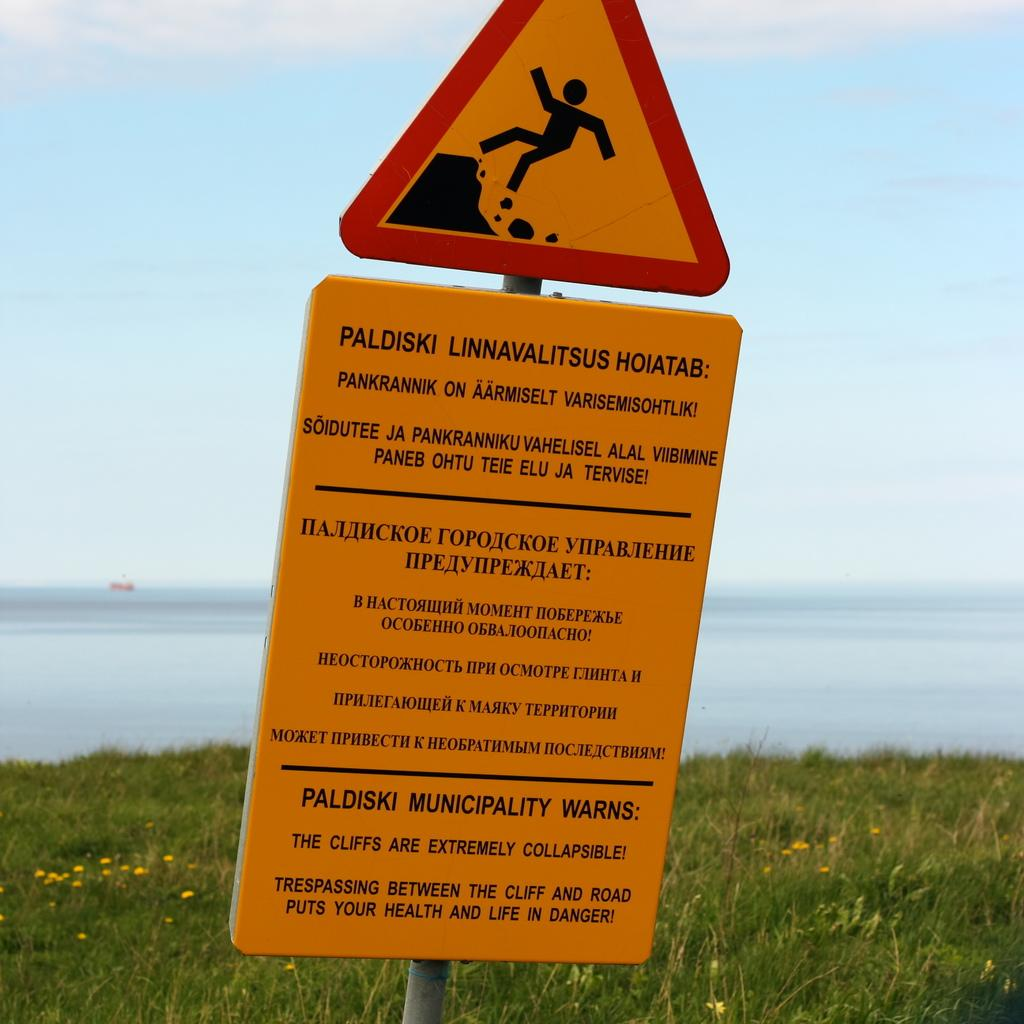Provide a one-sentence caption for the provided image. A sign warning of cliffs that are vulnerable to collapsing in Paldiski. 